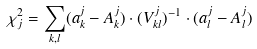<formula> <loc_0><loc_0><loc_500><loc_500>\chi ^ { 2 } _ { j } = \sum _ { k , l } ( a ^ { j } _ { k } - A ^ { j } _ { k } ) \cdot ( V ^ { j } _ { k l } ) ^ { - 1 } \cdot ( a ^ { j } _ { l } - A ^ { j } _ { l } )</formula> 